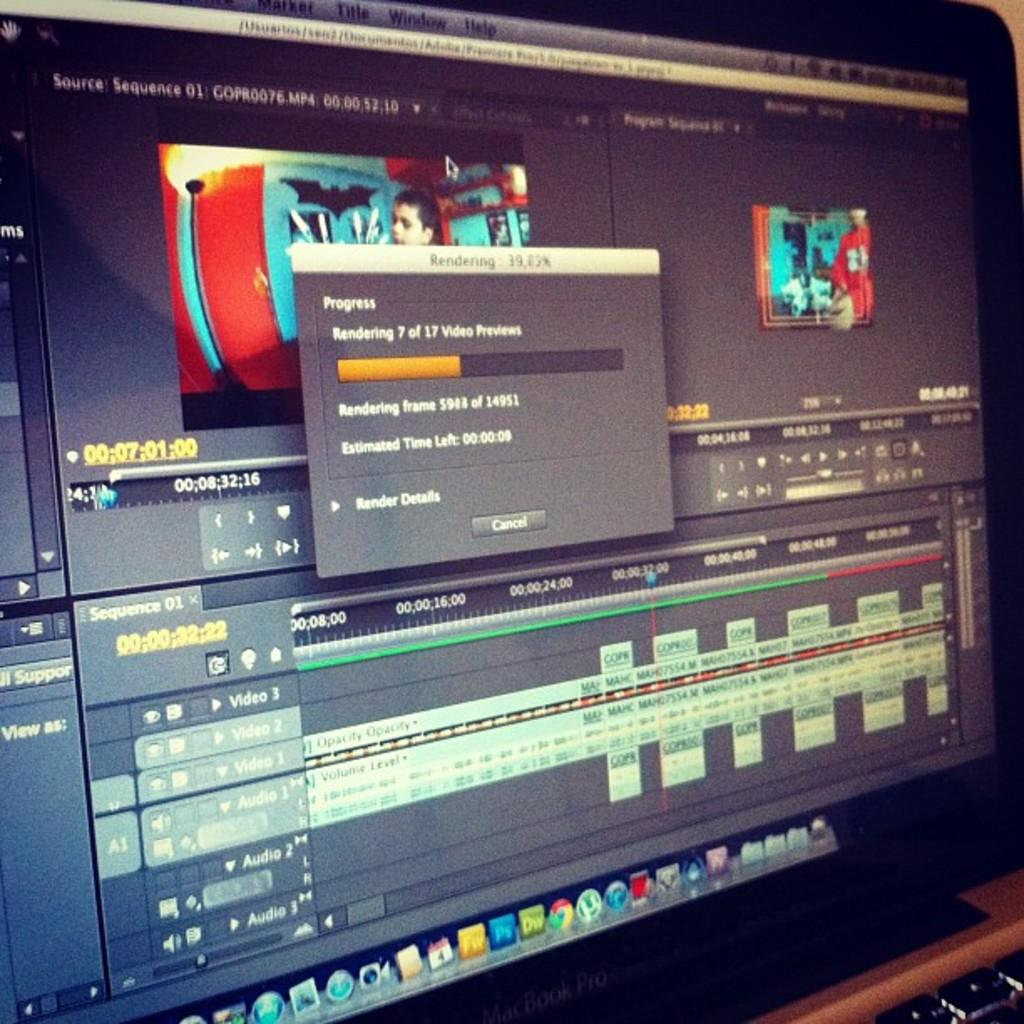<image>
Relay a brief, clear account of the picture shown. A pop up window is labeled rendering and shows the progress and estimated time left. 